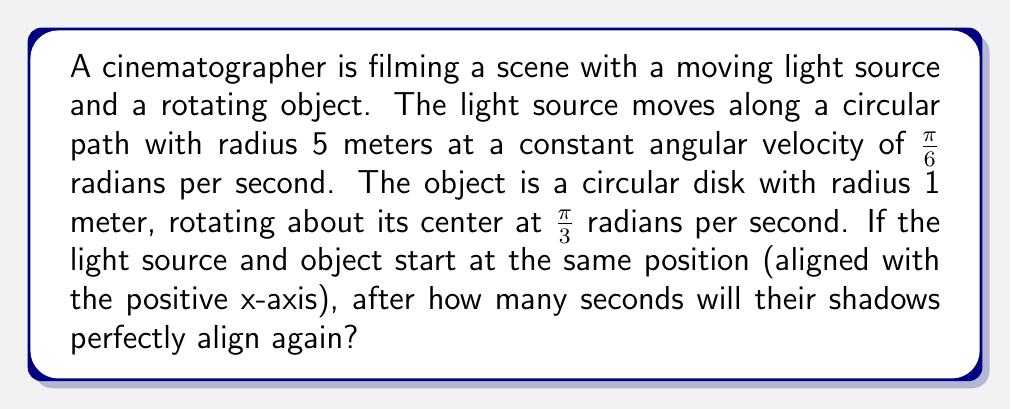Show me your answer to this math problem. To solve this problem, we need to consider the periodic motion of both the light source and the object:

1. Light source motion:
   - Angular velocity: $\omega_l = \frac{\pi}{6}$ rad/s
   - Period: $T_l = \frac{2\pi}{\omega_l} = \frac{2\pi}{\frac{\pi}{6}} = 12$ seconds

2. Object rotation:
   - Angular velocity: $\omega_o = \frac{\pi}{3}$ rad/s
   - Period: $T_o = \frac{2\pi}{\omega_o} = \frac{2\pi}{\frac{\pi}{3}} = 6$ seconds

3. To find when the shadows align, we need to find the least common multiple (LCM) of their periods:
   $LCM(12, 6) = 12$ seconds

4. However, due to the circular nature of the motion, the shadows will align twice during one complete cycle of the light source:
   - Once when they are in the same position
   - Once when they are in opposite positions (180° apart)

5. Therefore, the time for the first alignment after the initial position is half of the LCM:
   $t = \frac{12}{2} = 6$ seconds

This means the shadows will perfectly align every 6 seconds after the initial position.
Answer: 6 seconds 